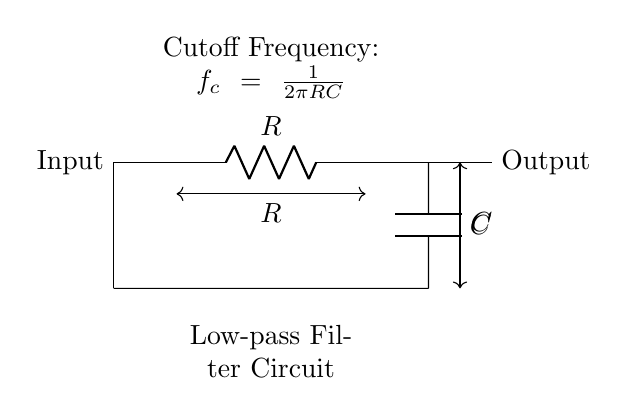What components are present in this circuit? The circuit consists of a resistor and a capacitor, indicated by their labels (R and C).
Answer: Resistor and Capacitor What is the function of this circuit? This circuit functions as a low-pass filter, allowing low-frequency signals to pass while attenuating higher frequencies.
Answer: Low-pass filter What is the cutoff frequency formula represented in the circuit? The cutoff frequency of the filter is expressed as \(f_c = \frac{1}{2\pi RC}\), showing the relationship between frequency, resistance, and capacitance.
Answer: f_c = 1/(2πRC) What is the output connection in the circuit? The output is taken from the junction where the capacitor connects to ground, and it represents the filtered signal.
Answer: Output How does increasing the capacitor affect the cutoff frequency? Increasing the capacitance (C) lowers the cutoff frequency since it is inversely proportional to C in the formula.
Answer: Lowers cutoff frequency What is the significance of the resistor in this circuit? The resistor (R) controls the rate of voltage change across the capacitor, affecting the filtering characteristics by determining the cutoff frequency alongside C.
Answer: Controls cutoff frequency 